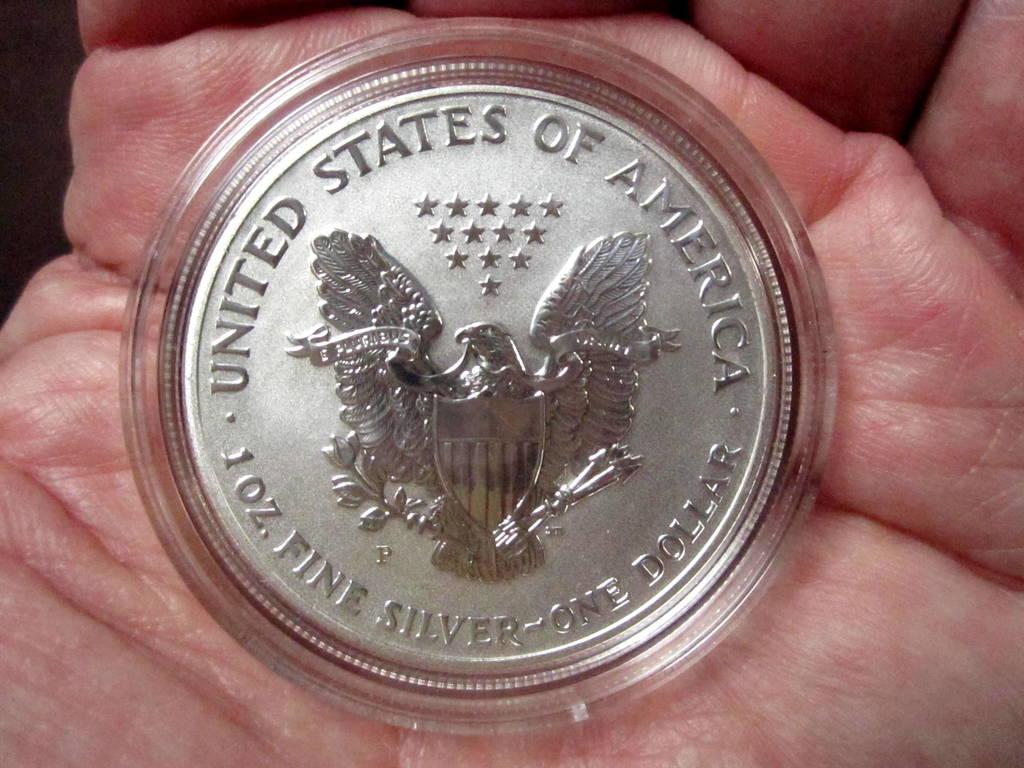<image>
Write a terse but informative summary of the picture. A person holding a silver coin that states 1 oz. fine silver. 